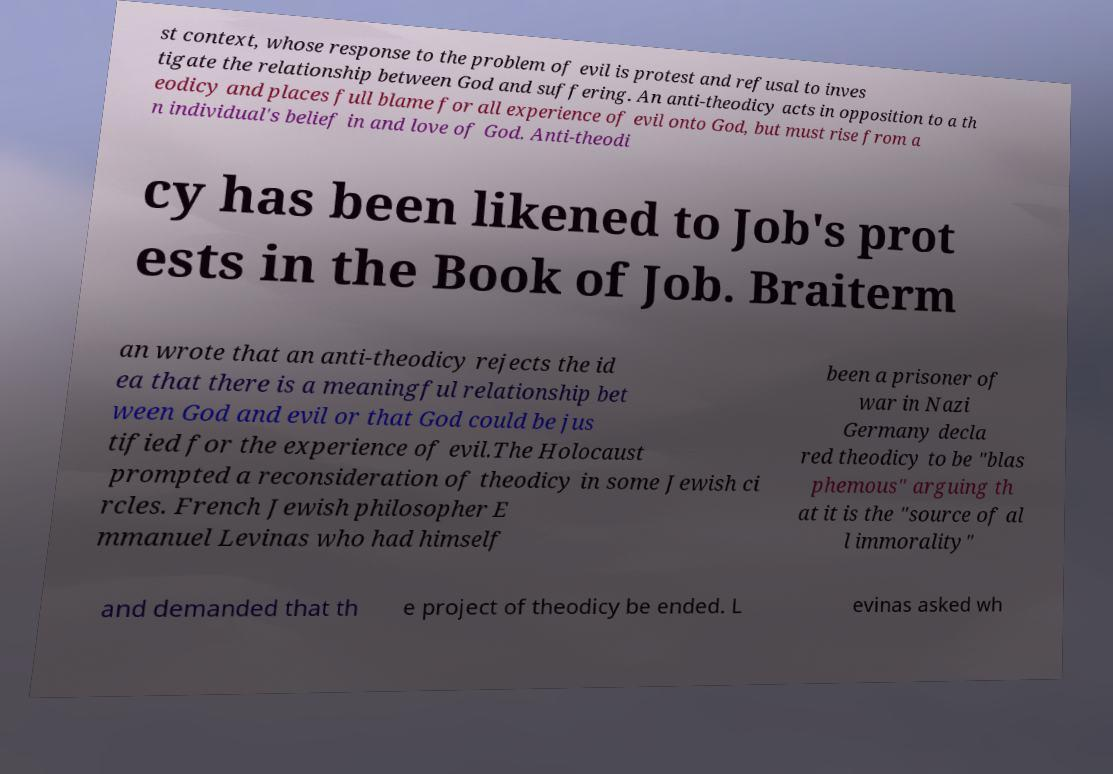I need the written content from this picture converted into text. Can you do that? st context, whose response to the problem of evil is protest and refusal to inves tigate the relationship between God and suffering. An anti-theodicy acts in opposition to a th eodicy and places full blame for all experience of evil onto God, but must rise from a n individual's belief in and love of God. Anti-theodi cy has been likened to Job's prot ests in the Book of Job. Braiterm an wrote that an anti-theodicy rejects the id ea that there is a meaningful relationship bet ween God and evil or that God could be jus tified for the experience of evil.The Holocaust prompted a reconsideration of theodicy in some Jewish ci rcles. French Jewish philosopher E mmanuel Levinas who had himself been a prisoner of war in Nazi Germany decla red theodicy to be "blas phemous" arguing th at it is the "source of al l immorality" and demanded that th e project of theodicy be ended. L evinas asked wh 